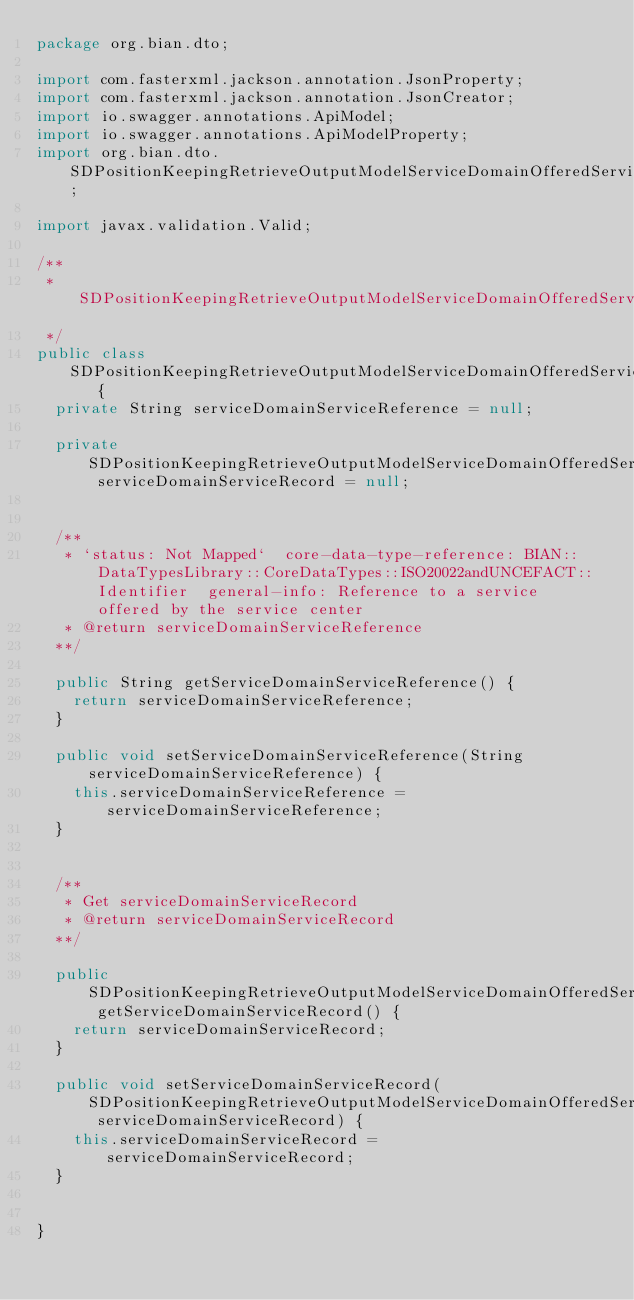Convert code to text. <code><loc_0><loc_0><loc_500><loc_500><_Java_>package org.bian.dto;

import com.fasterxml.jackson.annotation.JsonProperty;
import com.fasterxml.jackson.annotation.JsonCreator;
import io.swagger.annotations.ApiModel;
import io.swagger.annotations.ApiModelProperty;
import org.bian.dto.SDPositionKeepingRetrieveOutputModelServiceDomainOfferedServiceServiceDomainServiceRecord;

import javax.validation.Valid;
  
/**
 * SDPositionKeepingRetrieveOutputModelServiceDomainOfferedService
 */
public class SDPositionKeepingRetrieveOutputModelServiceDomainOfferedService   {
  private String serviceDomainServiceReference = null;

  private SDPositionKeepingRetrieveOutputModelServiceDomainOfferedServiceServiceDomainServiceRecord serviceDomainServiceRecord = null;


  /**
   * `status: Not Mapped`  core-data-type-reference: BIAN::DataTypesLibrary::CoreDataTypes::ISO20022andUNCEFACT::Identifier  general-info: Reference to a service offered by the service center 
   * @return serviceDomainServiceReference
  **/

  public String getServiceDomainServiceReference() {
    return serviceDomainServiceReference;
  }

  public void setServiceDomainServiceReference(String serviceDomainServiceReference) {
    this.serviceDomainServiceReference = serviceDomainServiceReference;
  }


  /**
   * Get serviceDomainServiceRecord
   * @return serviceDomainServiceRecord
  **/

  public SDPositionKeepingRetrieveOutputModelServiceDomainOfferedServiceServiceDomainServiceRecord getServiceDomainServiceRecord() {
    return serviceDomainServiceRecord;
  }

  public void setServiceDomainServiceRecord(SDPositionKeepingRetrieveOutputModelServiceDomainOfferedServiceServiceDomainServiceRecord serviceDomainServiceRecord) {
    this.serviceDomainServiceRecord = serviceDomainServiceRecord;
  }


}

</code> 